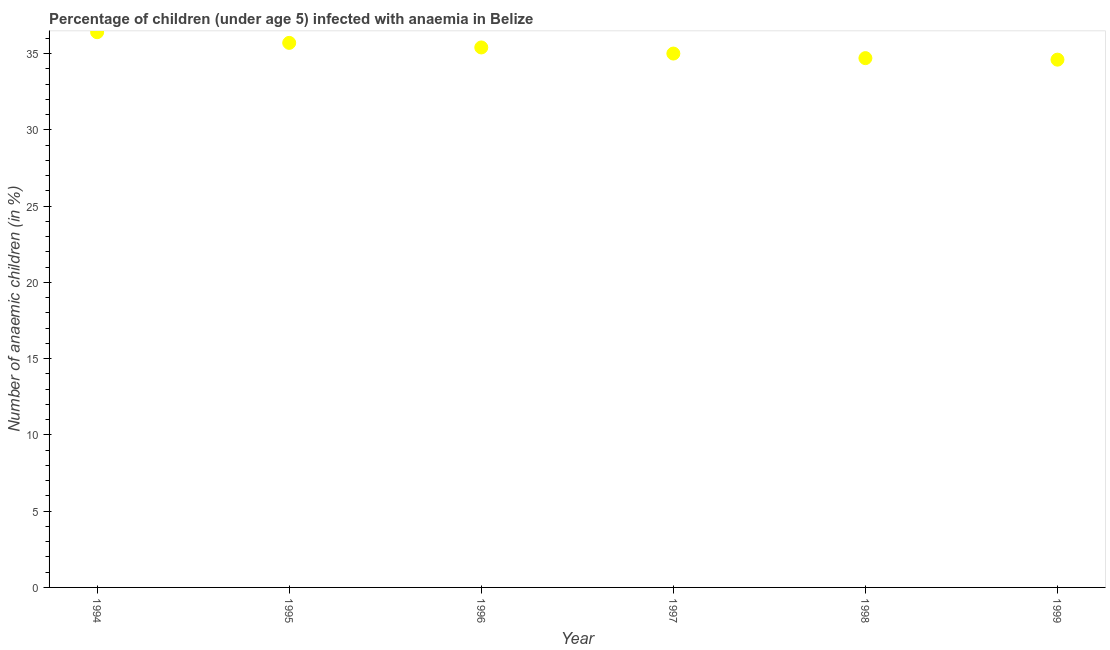What is the number of anaemic children in 1995?
Your answer should be very brief. 35.7. Across all years, what is the maximum number of anaemic children?
Your response must be concise. 36.4. Across all years, what is the minimum number of anaemic children?
Offer a terse response. 34.6. In which year was the number of anaemic children minimum?
Your answer should be very brief. 1999. What is the sum of the number of anaemic children?
Keep it short and to the point. 211.8. What is the difference between the number of anaemic children in 1998 and 1999?
Provide a succinct answer. 0.1. What is the average number of anaemic children per year?
Make the answer very short. 35.3. What is the median number of anaemic children?
Keep it short and to the point. 35.2. What is the ratio of the number of anaemic children in 1994 to that in 1999?
Offer a terse response. 1.05. Is the difference between the number of anaemic children in 1995 and 1996 greater than the difference between any two years?
Offer a very short reply. No. What is the difference between the highest and the second highest number of anaemic children?
Your answer should be compact. 0.7. Is the sum of the number of anaemic children in 1996 and 1999 greater than the maximum number of anaemic children across all years?
Offer a very short reply. Yes. What is the difference between the highest and the lowest number of anaemic children?
Give a very brief answer. 1.8. Does the number of anaemic children monotonically increase over the years?
Keep it short and to the point. No. Are the values on the major ticks of Y-axis written in scientific E-notation?
Offer a terse response. No. Does the graph contain any zero values?
Make the answer very short. No. What is the title of the graph?
Your answer should be very brief. Percentage of children (under age 5) infected with anaemia in Belize. What is the label or title of the X-axis?
Offer a very short reply. Year. What is the label or title of the Y-axis?
Keep it short and to the point. Number of anaemic children (in %). What is the Number of anaemic children (in %) in 1994?
Provide a short and direct response. 36.4. What is the Number of anaemic children (in %) in 1995?
Offer a terse response. 35.7. What is the Number of anaemic children (in %) in 1996?
Offer a terse response. 35.4. What is the Number of anaemic children (in %) in 1997?
Offer a terse response. 35. What is the Number of anaemic children (in %) in 1998?
Give a very brief answer. 34.7. What is the Number of anaemic children (in %) in 1999?
Keep it short and to the point. 34.6. What is the difference between the Number of anaemic children (in %) in 1994 and 1995?
Ensure brevity in your answer.  0.7. What is the difference between the Number of anaemic children (in %) in 1994 and 1998?
Provide a succinct answer. 1.7. What is the difference between the Number of anaemic children (in %) in 1994 and 1999?
Your response must be concise. 1.8. What is the difference between the Number of anaemic children (in %) in 1995 and 1996?
Your answer should be very brief. 0.3. What is the difference between the Number of anaemic children (in %) in 1995 and 1998?
Provide a short and direct response. 1. What is the difference between the Number of anaemic children (in %) in 1997 and 1998?
Offer a terse response. 0.3. What is the difference between the Number of anaemic children (in %) in 1997 and 1999?
Ensure brevity in your answer.  0.4. What is the ratio of the Number of anaemic children (in %) in 1994 to that in 1996?
Ensure brevity in your answer.  1.03. What is the ratio of the Number of anaemic children (in %) in 1994 to that in 1998?
Make the answer very short. 1.05. What is the ratio of the Number of anaemic children (in %) in 1994 to that in 1999?
Offer a terse response. 1.05. What is the ratio of the Number of anaemic children (in %) in 1995 to that in 1997?
Provide a succinct answer. 1.02. What is the ratio of the Number of anaemic children (in %) in 1995 to that in 1999?
Offer a terse response. 1.03. What is the ratio of the Number of anaemic children (in %) in 1996 to that in 1997?
Offer a terse response. 1.01. What is the ratio of the Number of anaemic children (in %) in 1996 to that in 1998?
Provide a succinct answer. 1.02. What is the ratio of the Number of anaemic children (in %) in 1997 to that in 1998?
Your response must be concise. 1.01. What is the ratio of the Number of anaemic children (in %) in 1997 to that in 1999?
Your response must be concise. 1.01. 